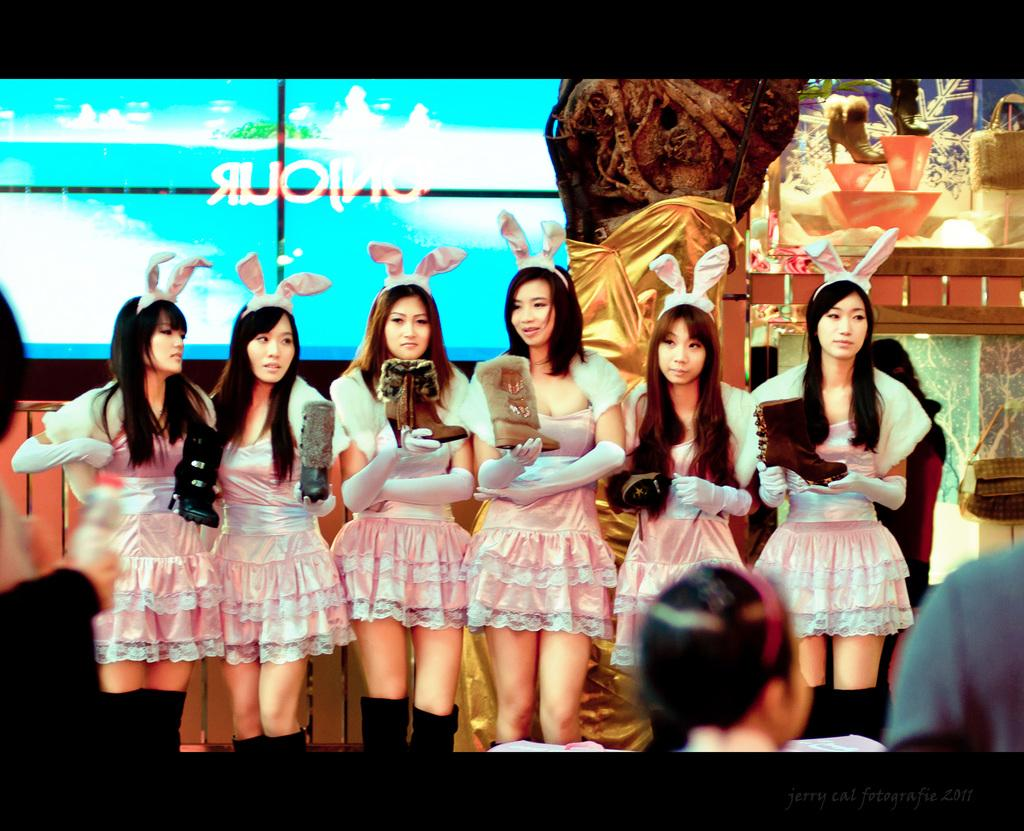How many people are in the image? There are persons in the image, but the exact number is not specified. What are the persons wearing? The persons are wearing clothes. What is located at the top of the image? There is a screen at the top of the image. What type of dolls can be seen crushing tomatoes in the image? There is no mention of dolls or tomatoes in the image, so this scenario cannot be observed. 